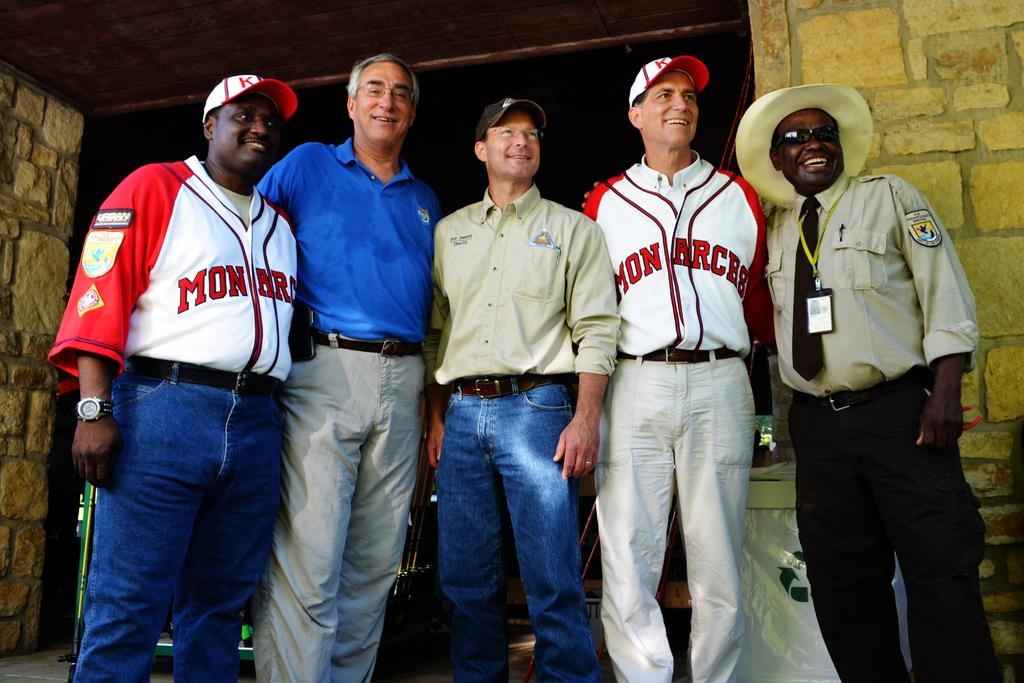<image>
Write a terse but informative summary of the picture. 5 men are lined up for a picture, 2 of them wearing Monarch jerseys 